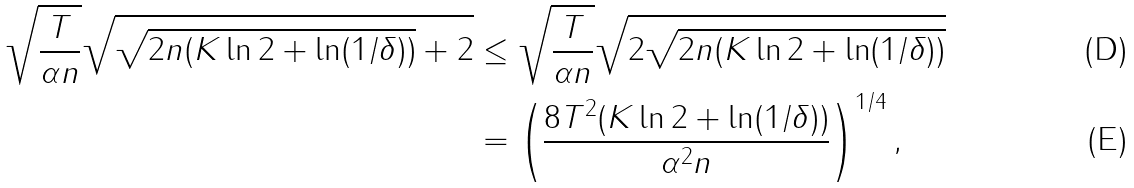Convert formula to latex. <formula><loc_0><loc_0><loc_500><loc_500>\sqrt { \frac { T } { \alpha n } } \sqrt { \sqrt { 2 n ( K \ln 2 + \ln ( 1 / \delta ) ) } + 2 } & \leq \sqrt { \frac { T } { \alpha n } } \sqrt { 2 \sqrt { 2 n ( K \ln 2 + \ln ( 1 / \delta ) ) } } \\ & = \left ( \frac { 8 T ^ { 2 } ( K \ln 2 + \ln ( 1 / \delta ) ) } { \alpha ^ { 2 } n } \right ) ^ { 1 / 4 } ,</formula> 